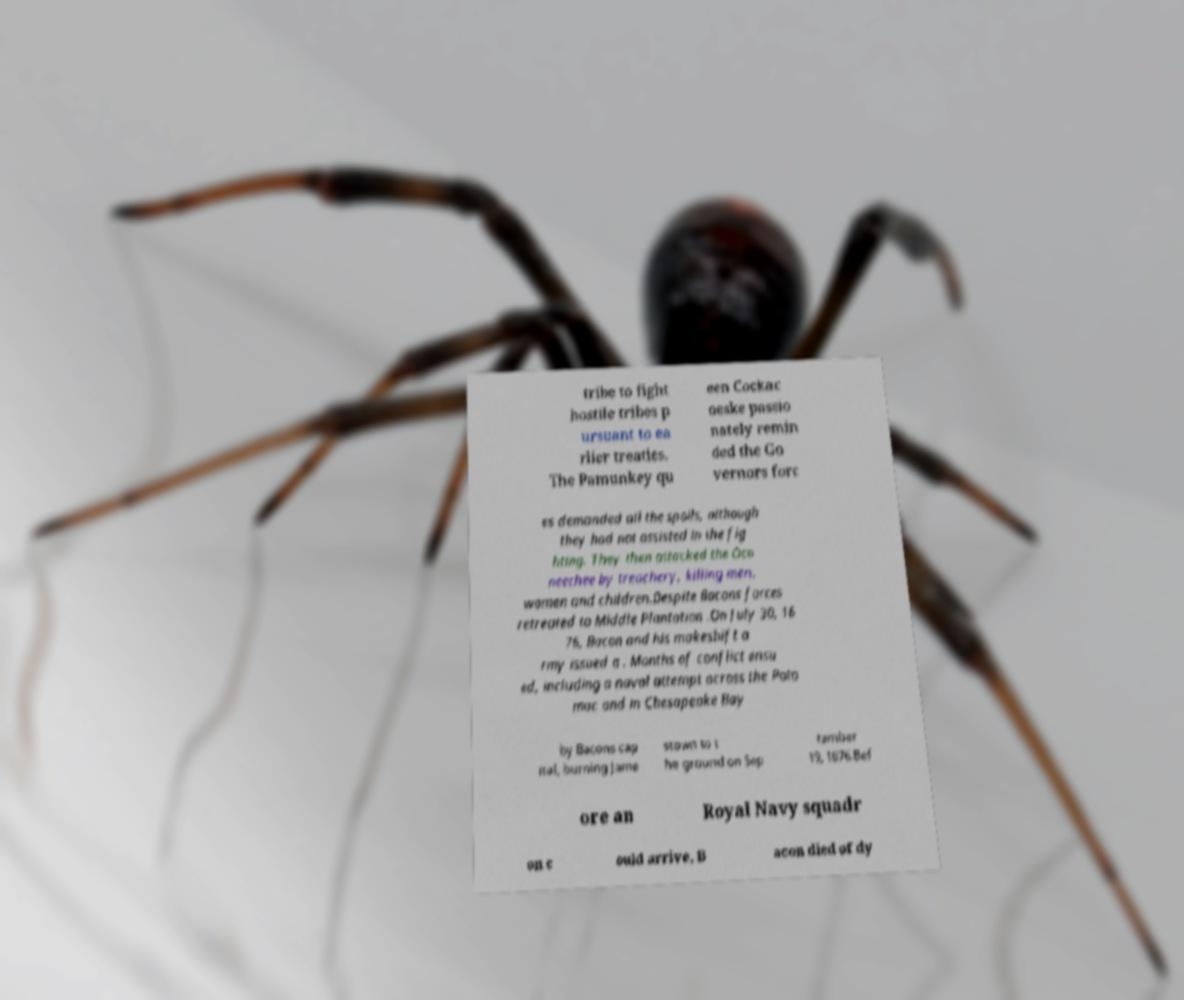Can you read and provide the text displayed in the image?This photo seems to have some interesting text. Can you extract and type it out for me? tribe to fight hostile tribes p ursuant to ea rlier treaties. The Pamunkey qu een Cockac oeske passio nately remin ded the Go vernors forc es demanded all the spoils, although they had not assisted in the fig hting. They then attacked the Oco neechee by treachery, killing men, women and children.Despite Bacons forces retreated to Middle Plantation .On July 30, 16 76, Bacon and his makeshift a rmy issued a . Months of conflict ensu ed, including a naval attempt across the Poto mac and in Chesapeake Bay by Bacons cap ital, burning Jame stown to t he ground on Sep tember 19, 1676.Bef ore an Royal Navy squadr on c ould arrive, B acon died of dy 